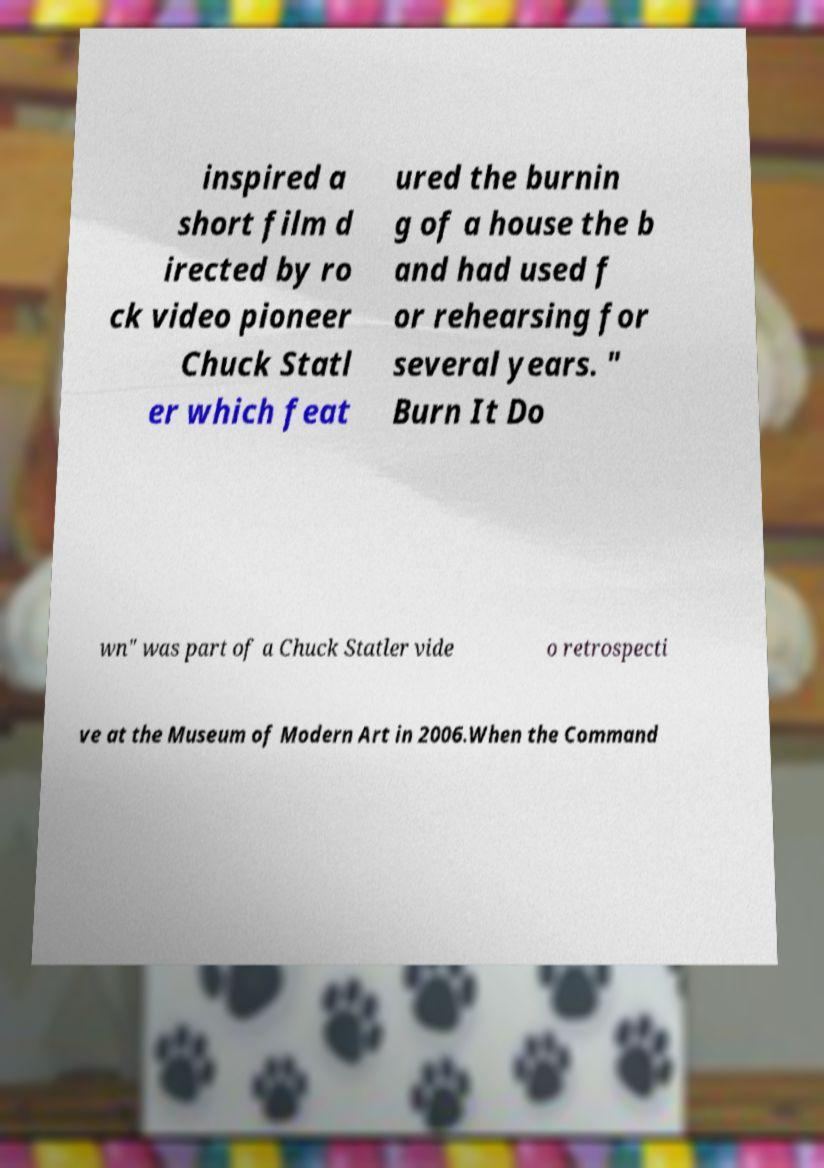There's text embedded in this image that I need extracted. Can you transcribe it verbatim? inspired a short film d irected by ro ck video pioneer Chuck Statl er which feat ured the burnin g of a house the b and had used f or rehearsing for several years. " Burn It Do wn" was part of a Chuck Statler vide o retrospecti ve at the Museum of Modern Art in 2006.When the Command 